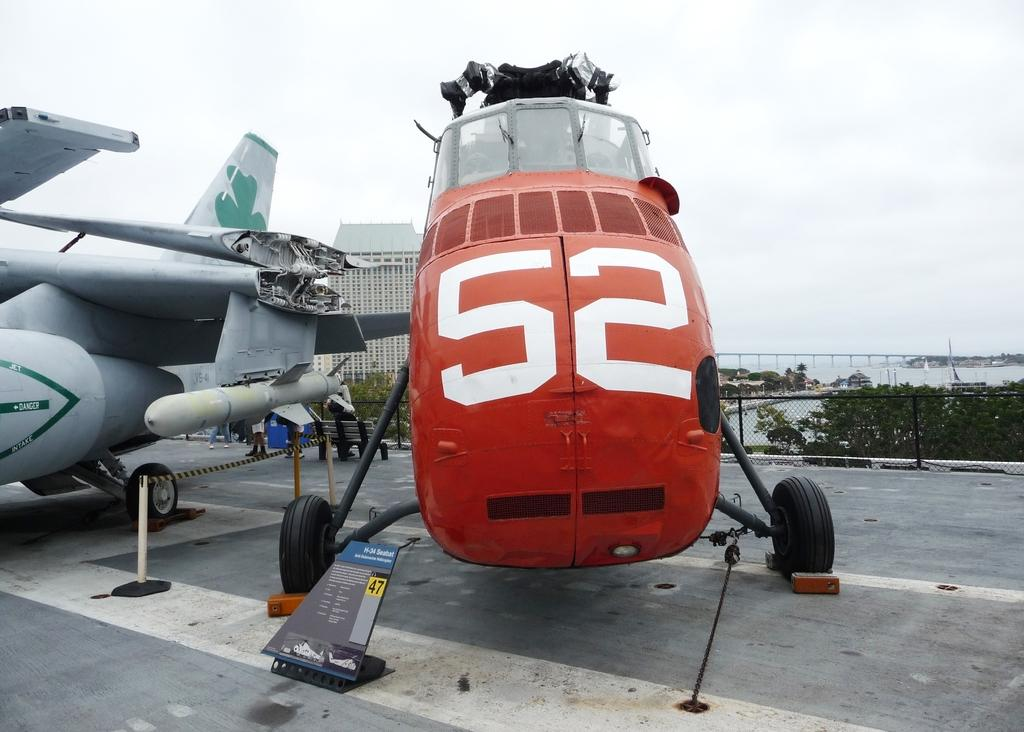What color is the airplane on the right side of the image? There is an orange airplane on the right side of the image. What color is the airplane on the left side of the image? There is a grey airplane on the left side of the image. What is the condition of the sky in the image? The sky is cloudy at the top of the image. What type of trick can be seen being performed by the airplanes in the image? There is no trick being performed by the airplanes in the image; they are simply depicted in their respective colors and positions. 